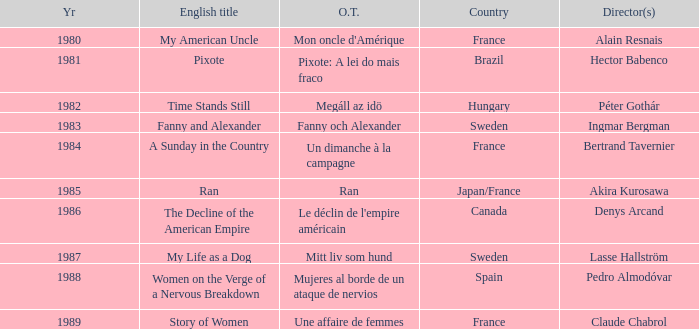What was the year of Megáll az Idö? 1982.0. 